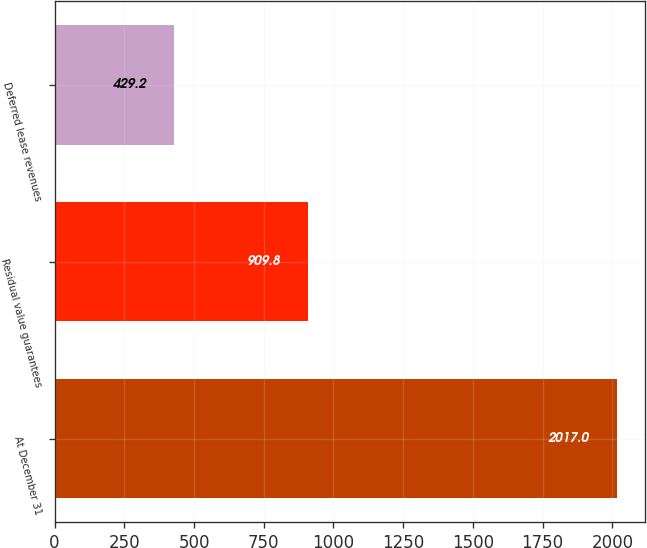Convert chart. <chart><loc_0><loc_0><loc_500><loc_500><bar_chart><fcel>At December 31<fcel>Residual value guarantees<fcel>Deferred lease revenues<nl><fcel>2017<fcel>909.8<fcel>429.2<nl></chart> 